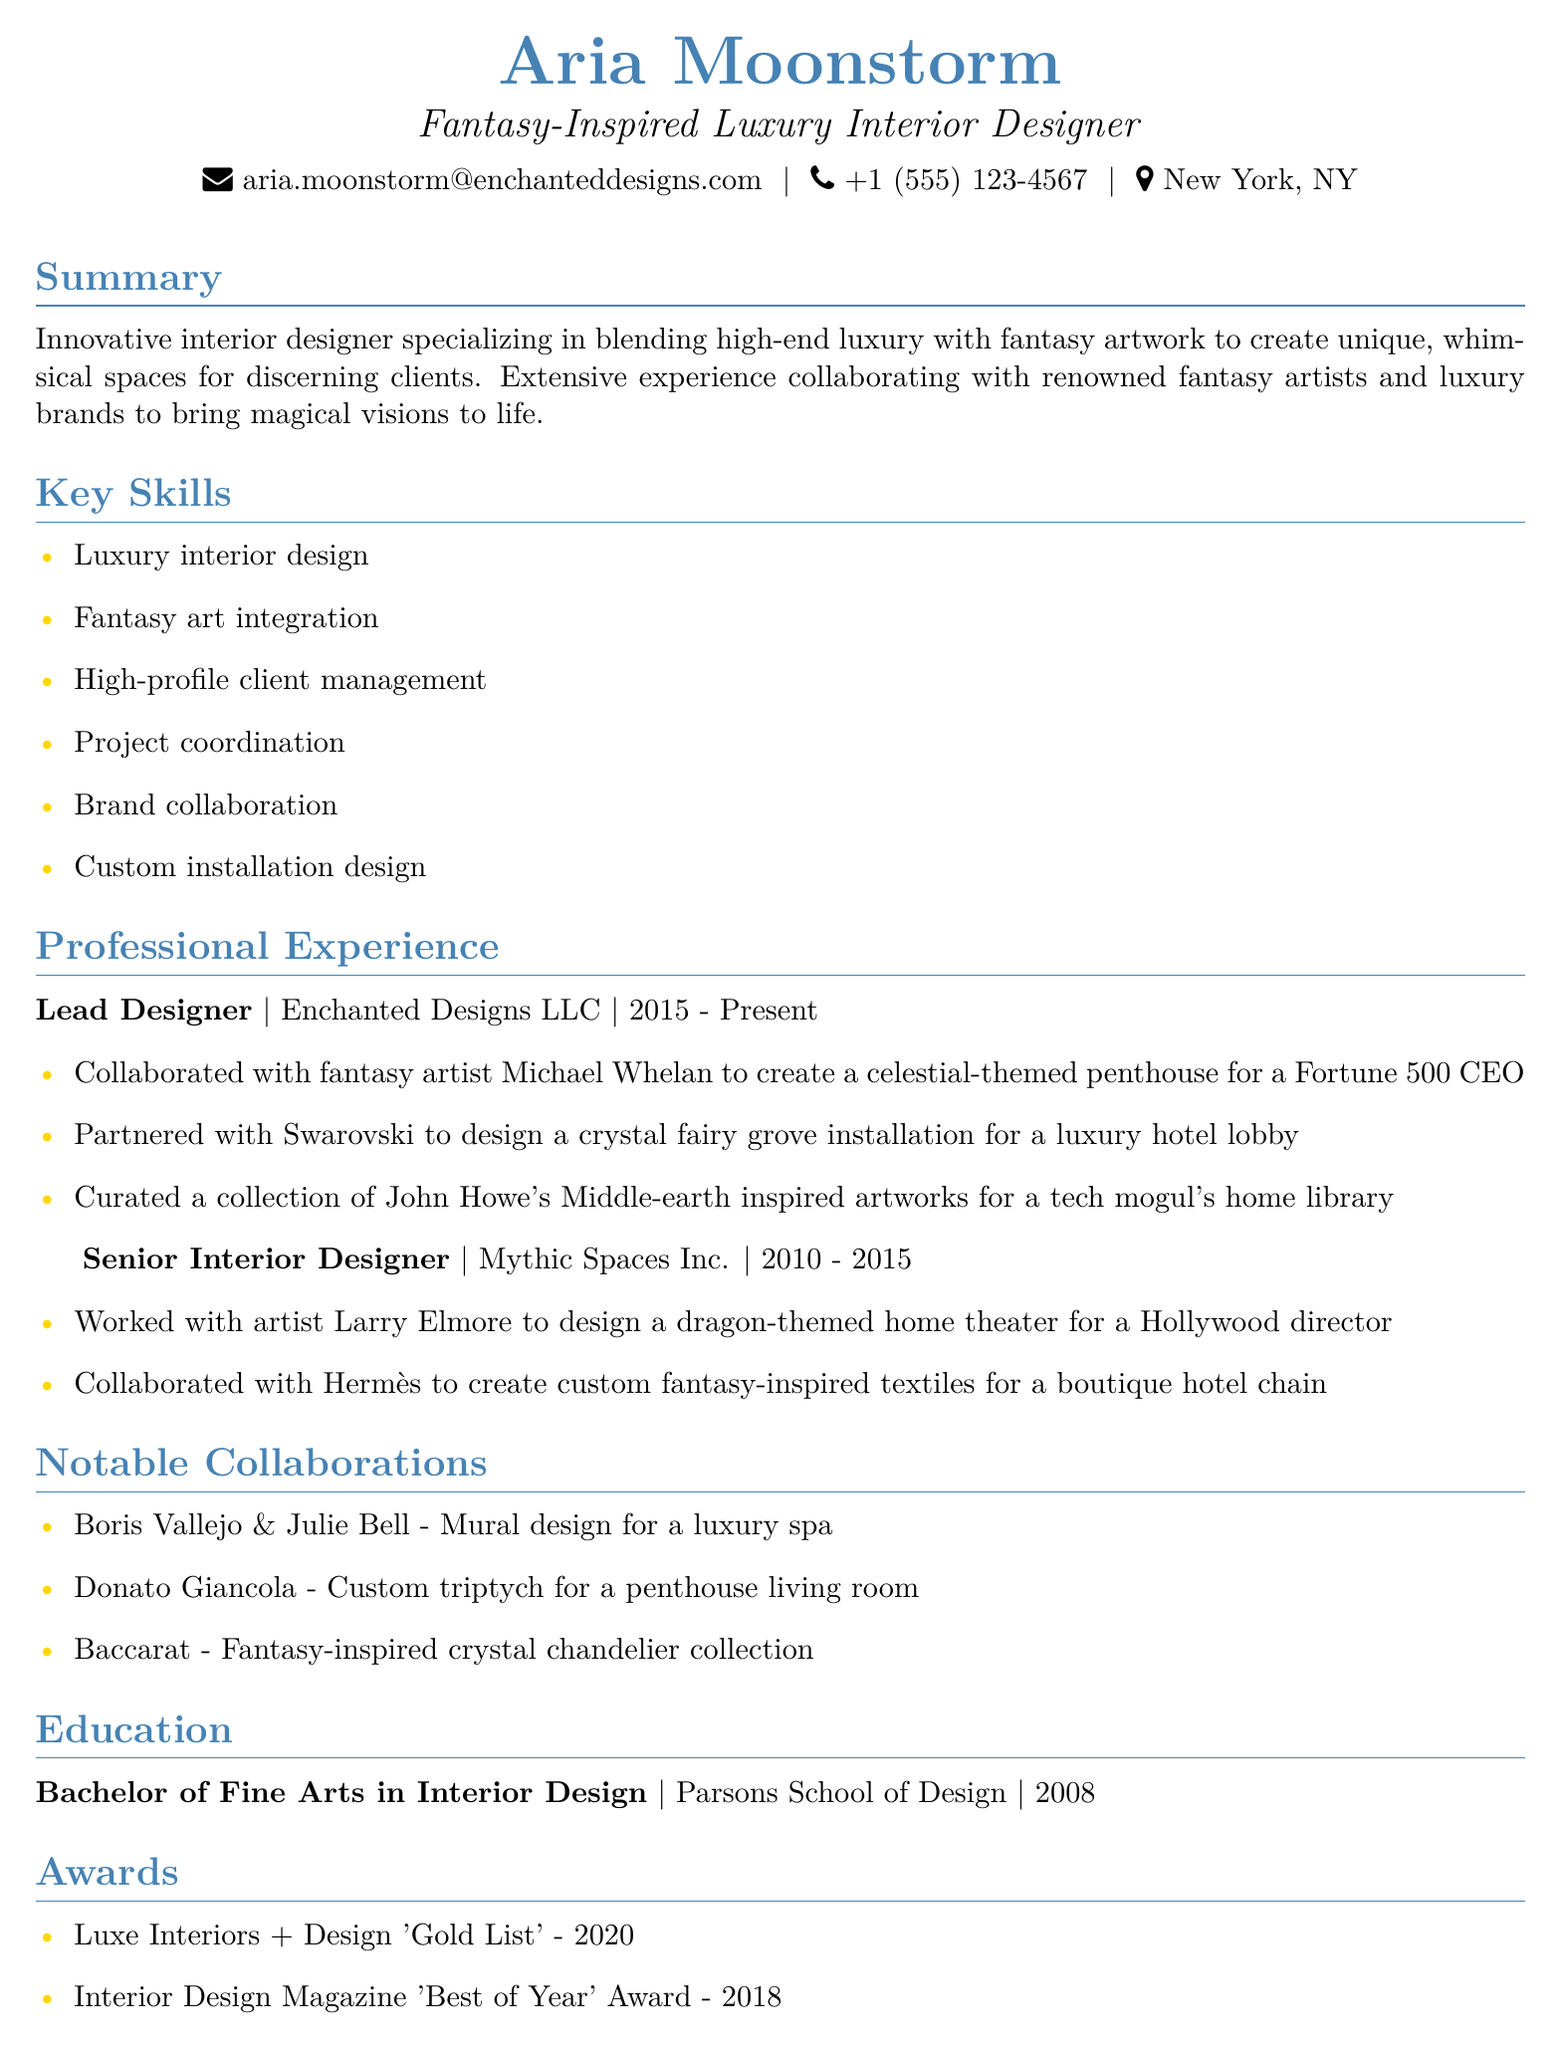what is the name of the designer? The name of the designer is stated prominently at the top of the document.
Answer: Aria Moonstorm what is the title of the designer? The title of the designer is directly below their name in the document.
Answer: Fantasy-Inspired Luxury Interior Designer what is the email address provided? The email address is listed in the contact section of the document.
Answer: aria.moonstorm@enchanteddesigns.com which company did Aria work for as a Lead Designer? The company name is mentioned in the professional experience section under the Lead Designer position.
Answer: Enchanted Designs LLC what year did Aria graduate from Parsons School of Design? The graduation year is provided in the education section of the document.
Answer: 2008 who did Aria collaborate with for a luxury hotel lobby installation? The collaborator is listed under the achievements for the Lead Designer role.
Answer: Swarovski how many years did Aria work at Mythic Spaces Inc.? The duration of employment at that company is mentioned in the professional experience section.
Answer: 5 years what award did Aria receive in 2020? The award is listed in the awards section of the document.
Answer: Luxe Interiors + Design 'Gold List' which two artists partnered with Aria for notable collaborations? These partnerships are specified in the notable collaborations section of the document.
Answer: Boris Vallejo & Julie Bell, Donato Giancola what kind of artwork did Aria integrate into high-end designs? This information is included in the summary section of the document.
Answer: Fantasy artwork 